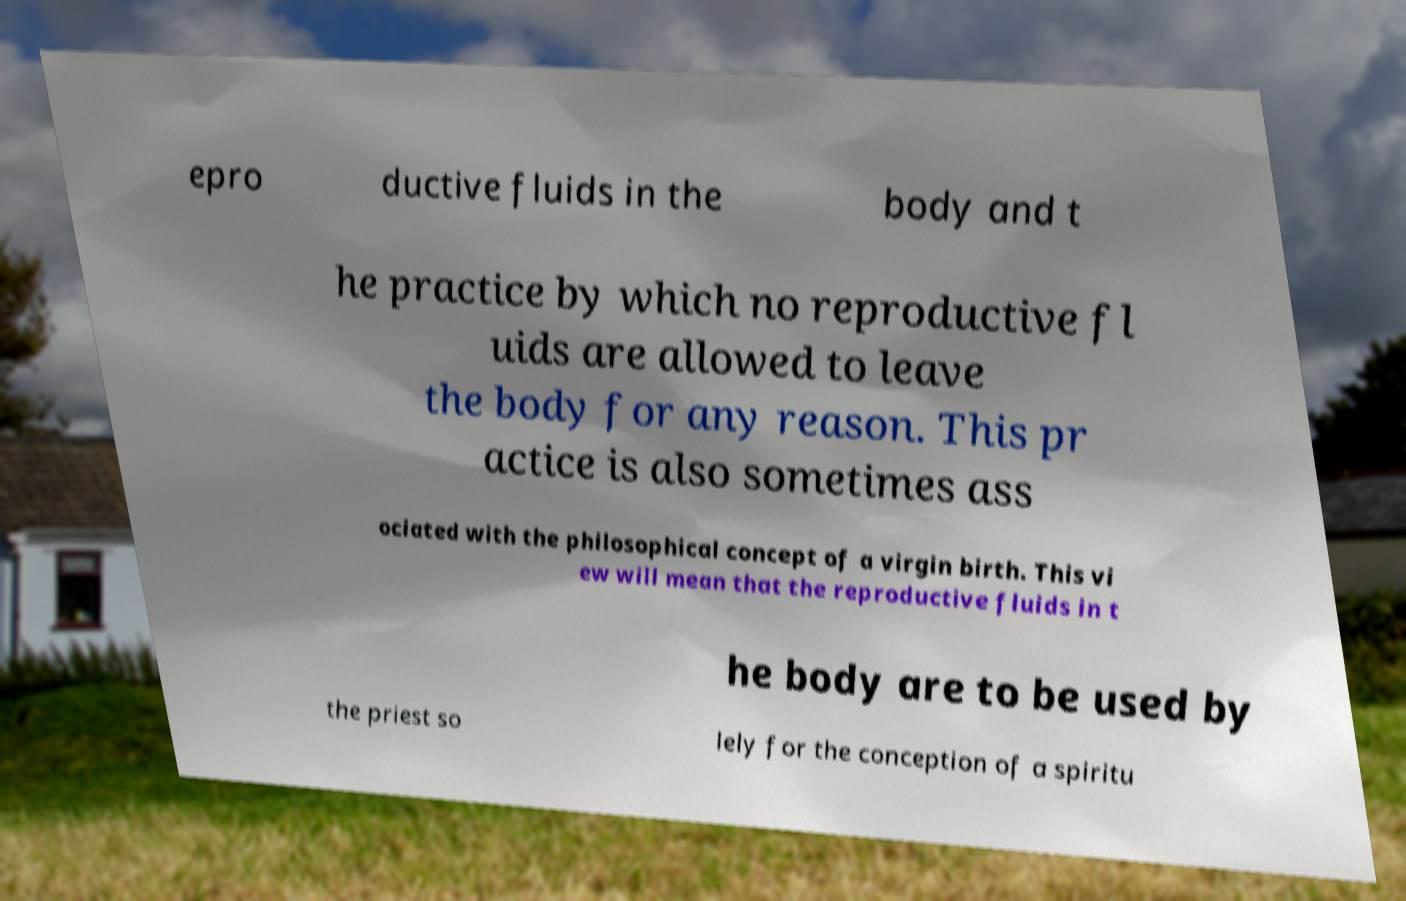Please identify and transcribe the text found in this image. epro ductive fluids in the body and t he practice by which no reproductive fl uids are allowed to leave the body for any reason. This pr actice is also sometimes ass ociated with the philosophical concept of a virgin birth. This vi ew will mean that the reproductive fluids in t he body are to be used by the priest so lely for the conception of a spiritu 